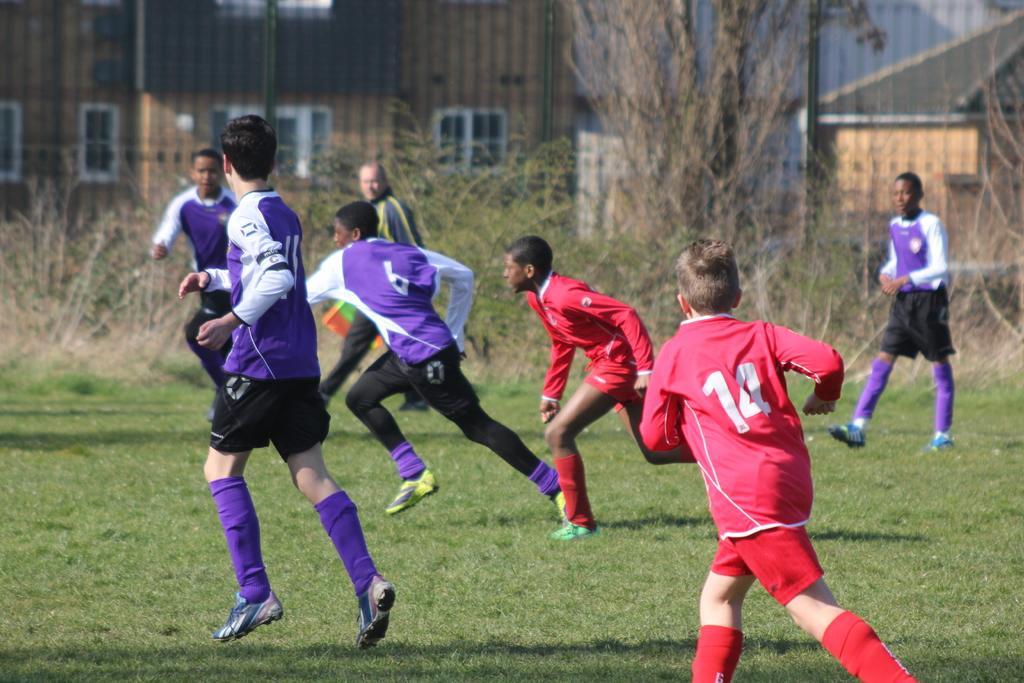In one or two sentences, can you explain what this image depicts? In this picture we can see a group of boys running on the ground and a man walking, grass, trees and in the background we can see buildings with windows. 